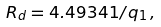Convert formula to latex. <formula><loc_0><loc_0><loc_500><loc_500>R _ { d } = 4 . 4 9 3 4 1 / q _ { 1 } \, ,</formula> 